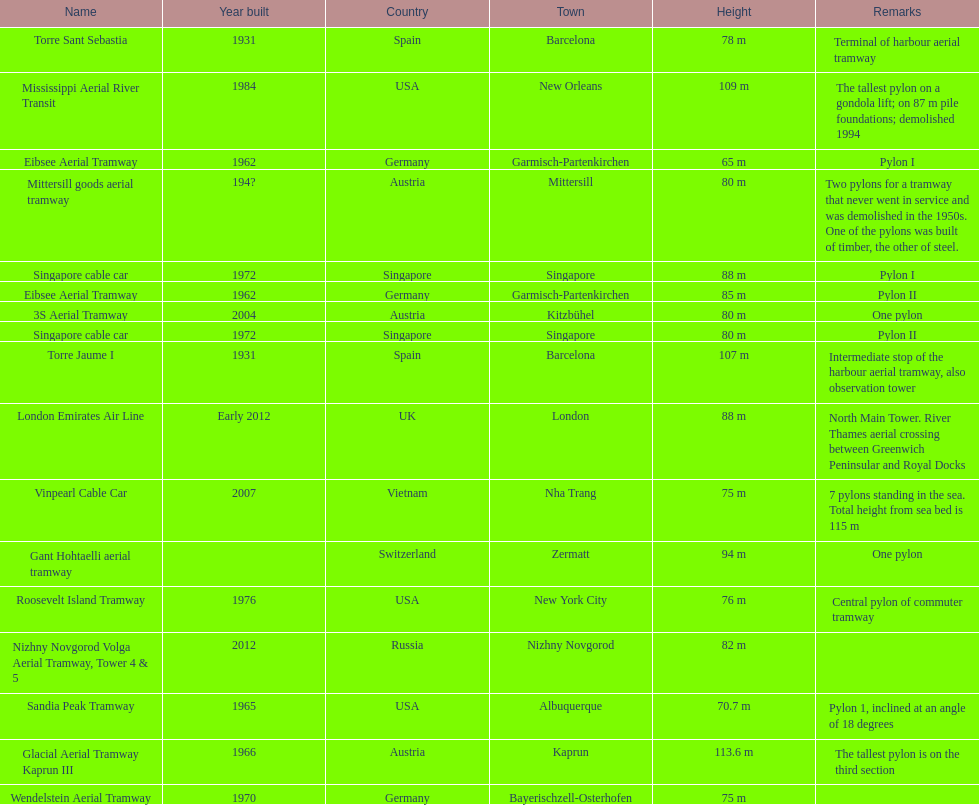What is the smallest height pylon listed here? Eibsee Aerial Tramway. 